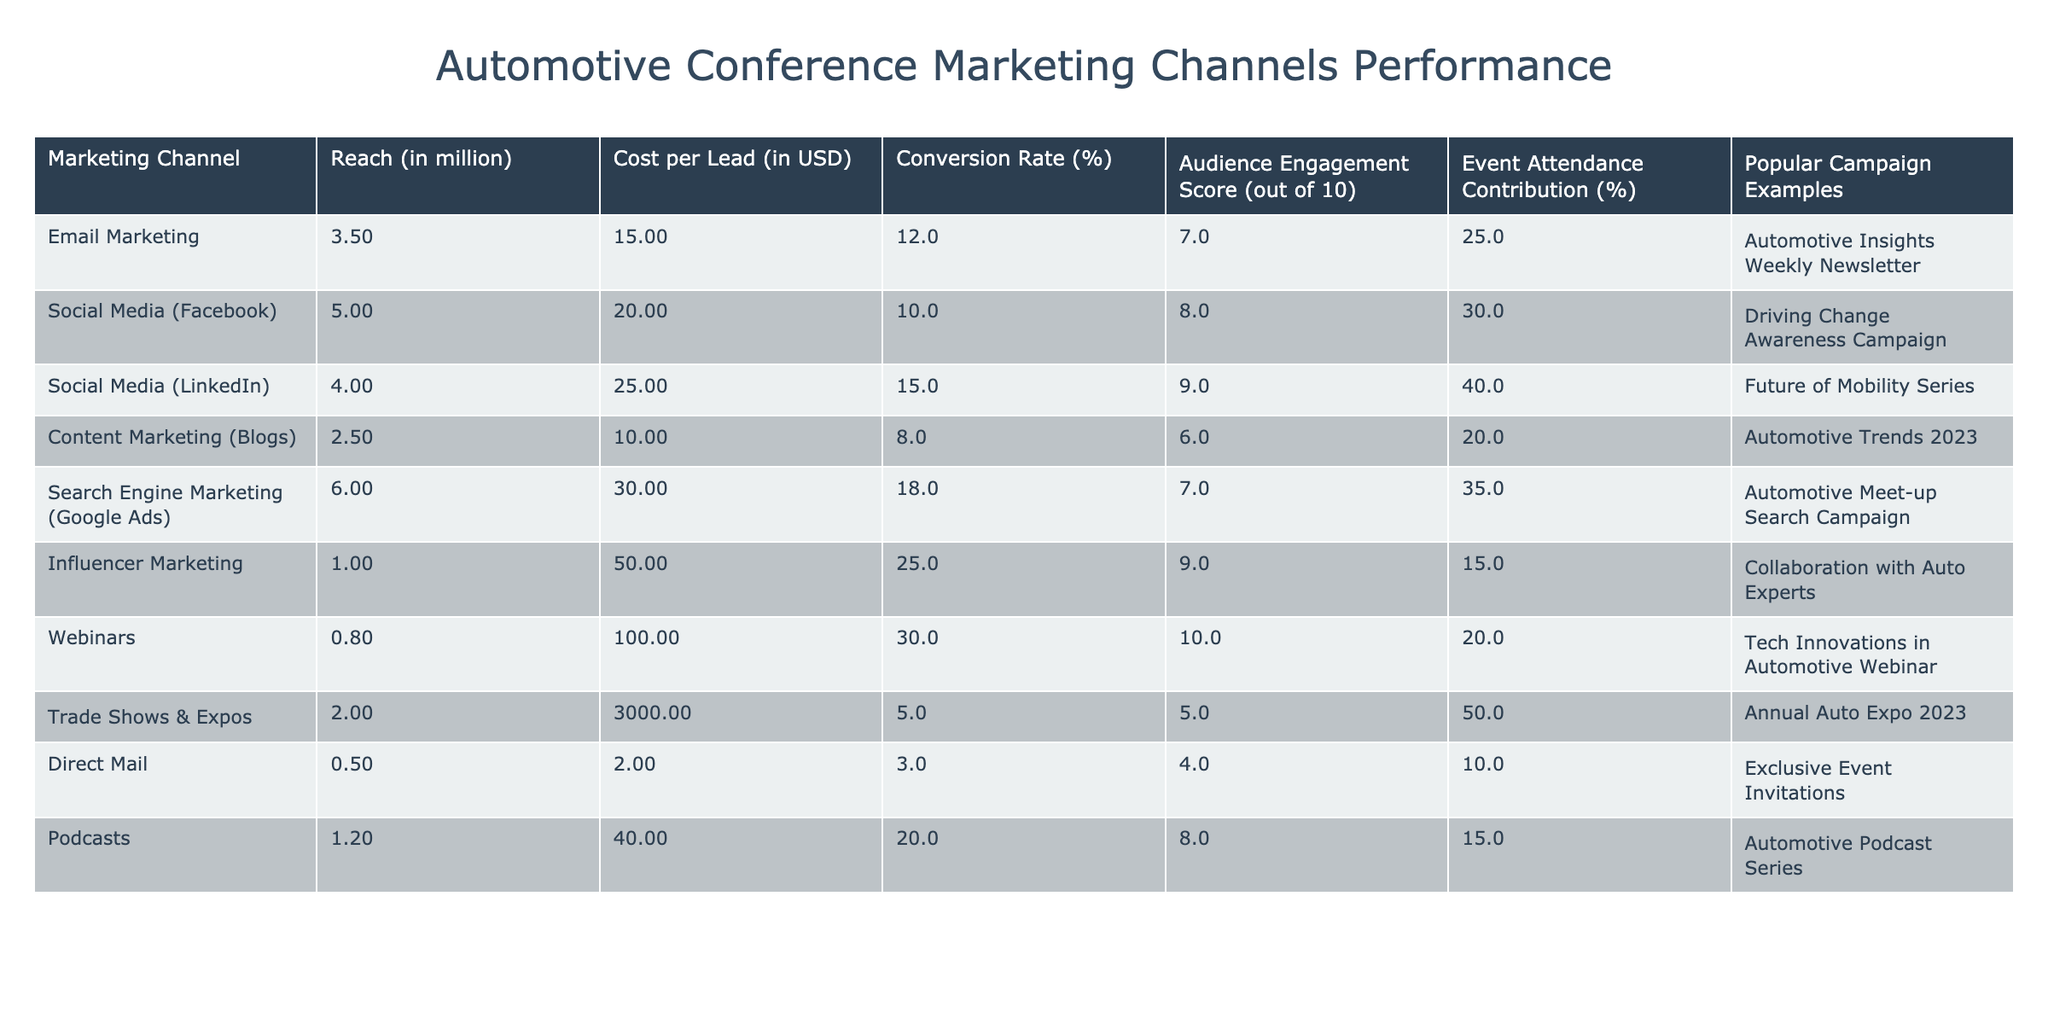What is the reach of Social Media (LinkedIn)? The table shows that the Reach for Social Media (LinkedIn) is 4.0 million.
Answer: 4.0 million Which marketing channel has the highest conversion rate? By comparing the Conversion Rates in the table, Webinars have the highest rate at 30%.
Answer: Webinars What is the total reach of all marketing channels listed? To find the total reach, add all the reach values: 3.5 + 5.0 + 4.0 + 2.5 + 6.0 + 1.0 + 0.8 + 2.0 + 0.5 + 1.2 = 27.5 million.
Answer: 27.5 million Does Direct Mail have a higher audience engagement score than Email Marketing? The Audience Engagement Score for Direct Mail is 4, and for Email Marketing, it is 7. Since 4 is less than 7, the answer is no.
Answer: No What is the average cost per lead across all marketing channels? Add all costs and divide by the total number of channels: (15 + 20 + 25 + 10 + 30 + 50 + 100 + 3000 + 2 + 40) = 3222, then divide by 10 = 322.2.
Answer: 322.2 Which marketing channel contributes the most to event attendance? The Event Attendance Contribution for Trade Shows & Expos is 50%, which is the highest among all channels.
Answer: Trade Shows & Expos If we exclude Trade Shows & Expos, what is the average conversion rate of the remaining channels? Exclude Trade Shows & Expos and calculate the average of the remaining conversion rates: (12 + 10 + 15 + 8 + 18 + 25 + 30 + 20 + 3) / 9 = 15.78.
Answer: 15.78 Is the Cost per Lead for Influencer Marketing greater than the Cost per Lead for Email Marketing? Influencer Marketing costs $50 per lead while Email Marketing costs $15 per lead. Since 50 is greater than 15, the answer is yes.
Answer: Yes What percentage of the total reach is attributed to Search Engine Marketing (Google Ads)? The total reach is 27.5 million, and Search Engine Marketing (Google Ads) has a reach of 6.0 million. The percentage is (6.0 / 27.5) * 100 = 21.82%.
Answer: 21.82% Which marketing channel combines the lowest cost per lead with the highest audience engagement score? Review the Cost per Lead and Audience Engagement Scores; Costs are lower for Email Marketing ($15) with an engagement score of 7 compared to others. Therefore, it has a balance of both metrics.
Answer: Email Marketing 